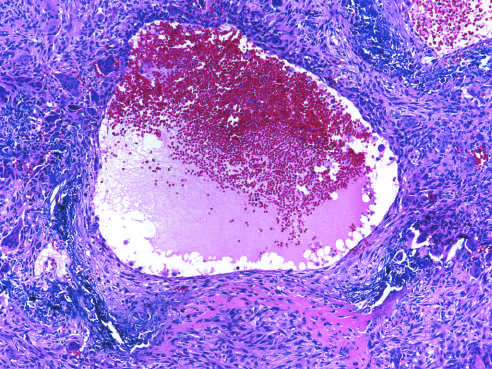what is the aneurysmal bone cyst with blood-filled cystic space surrounded by?
Answer the question using a single word or phrase. A fibrous wall containing proliferating fibroblasts 